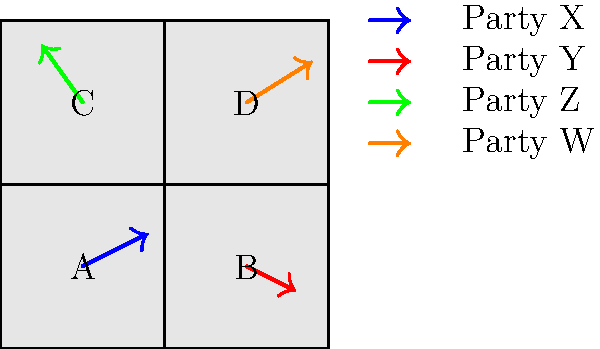Given the map of four regions (A, B, C, and D) with vector arrows representing political party support, which party appears to have the strongest overall support across all regions, and what might this suggest about the political landscape in Russia? To analyze the political party support across the regions:

1. Examine each region:
   Region A: Party X (blue arrow) has moderate support.
   Region B: Party Y (red arrow) has moderate support.
   Region C: Party Z (green arrow) has strong support.
   Region D: Party W (orange arrow) has strong support.

2. Compare arrow lengths:
   Longer arrows indicate stronger support.
   Parties Z and W have the longest arrows.

3. Assess overall presence:
   Party X is present in 1 region.
   Party Y is present in 1 region.
   Party Z is present in 1 region.
   Party W is present in 1 region.

4. Consider regional distribution:
   All parties have support in different regions, suggesting a diverse political landscape.

5. Evaluate strongest overall support:
   Party W has the longest arrow and is present in a populous region (assuming D is urban).

6. Interpret the political landscape:
   The diversity of strong parties in different regions suggests a fragmented political system, possibly reflecting regional interests or ethnic divisions in Russia.

7. Consider implications:
   This fragmentation might indicate challenges for national governance and the need for coalition-building in the Russian political system.
Answer: Party W; indicates fragmented political landscape with strong regional differences. 